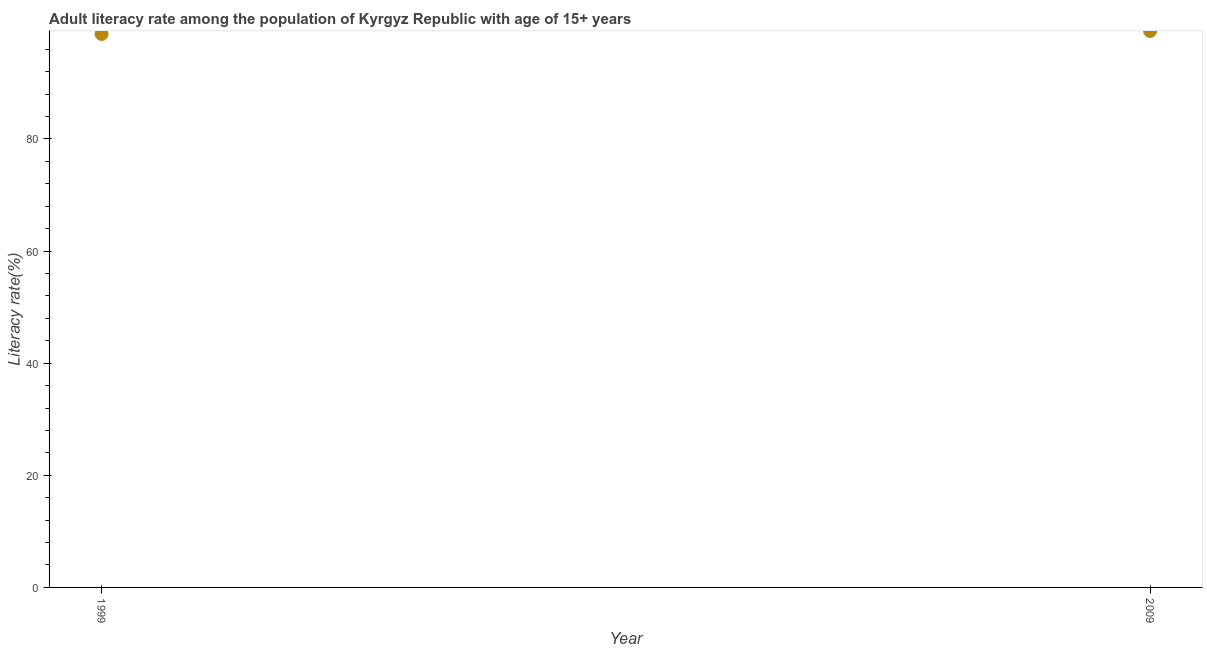What is the adult literacy rate in 1999?
Offer a very short reply. 98.7. Across all years, what is the maximum adult literacy rate?
Give a very brief answer. 99.24. Across all years, what is the minimum adult literacy rate?
Your answer should be compact. 98.7. In which year was the adult literacy rate maximum?
Your answer should be compact. 2009. What is the sum of the adult literacy rate?
Offer a terse response. 197.94. What is the difference between the adult literacy rate in 1999 and 2009?
Provide a short and direct response. -0.54. What is the average adult literacy rate per year?
Provide a succinct answer. 98.97. What is the median adult literacy rate?
Make the answer very short. 98.97. What is the ratio of the adult literacy rate in 1999 to that in 2009?
Offer a terse response. 0.99. Is the adult literacy rate in 1999 less than that in 2009?
Give a very brief answer. Yes. In how many years, is the adult literacy rate greater than the average adult literacy rate taken over all years?
Your response must be concise. 1. Does the adult literacy rate monotonically increase over the years?
Give a very brief answer. Yes. How many dotlines are there?
Keep it short and to the point. 1. Are the values on the major ticks of Y-axis written in scientific E-notation?
Make the answer very short. No. Does the graph contain any zero values?
Your answer should be very brief. No. What is the title of the graph?
Provide a short and direct response. Adult literacy rate among the population of Kyrgyz Republic with age of 15+ years. What is the label or title of the X-axis?
Provide a short and direct response. Year. What is the label or title of the Y-axis?
Your answer should be compact. Literacy rate(%). What is the Literacy rate(%) in 1999?
Your answer should be compact. 98.7. What is the Literacy rate(%) in 2009?
Your answer should be compact. 99.24. What is the difference between the Literacy rate(%) in 1999 and 2009?
Keep it short and to the point. -0.54. 